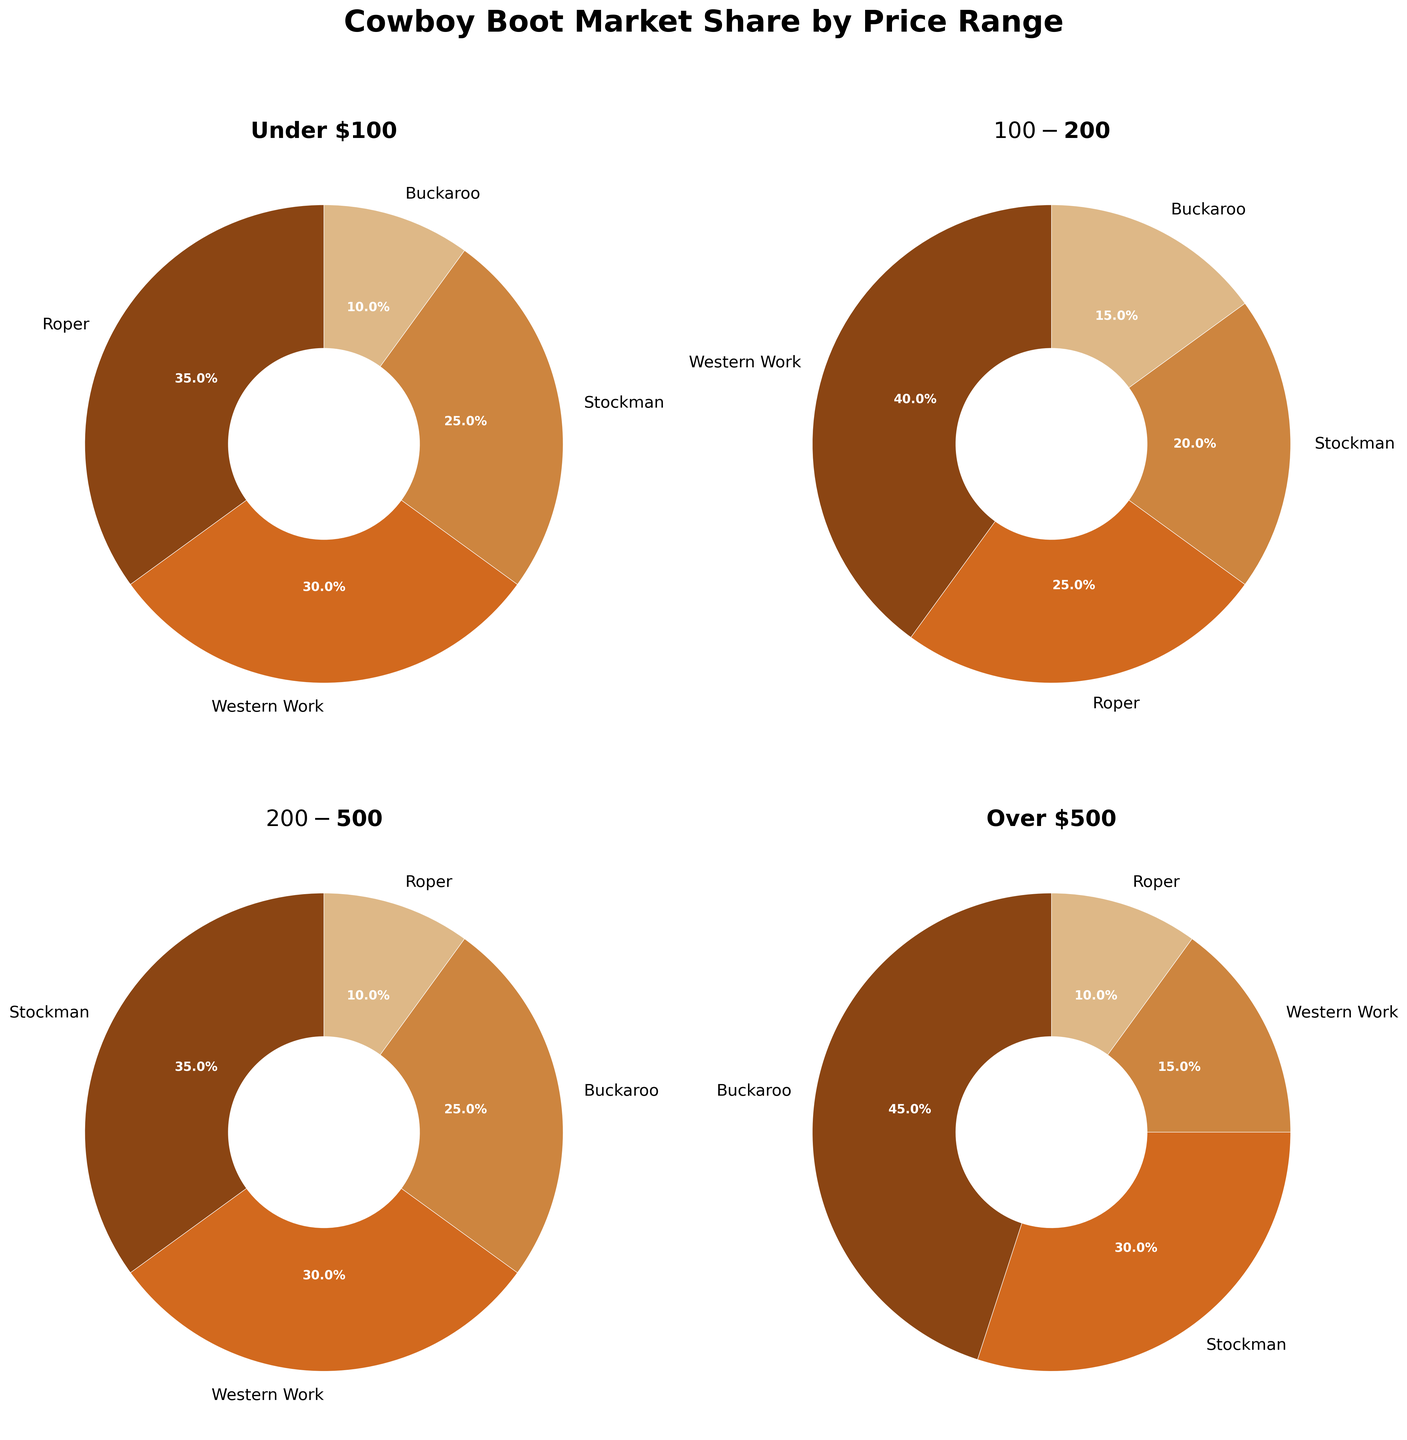What's the most popular boot style under $100? Look at the pie chart for the "Under $100" price range. The largest slice of the pie chart corresponds to the "Roper" style with 35%.
Answer: Roper Which style got the most market share in the $100-$200 range? Refer to the pie chart for the "$100-$200" range and identify the largest segment. "Western Work" has the highest market share with 40%.
Answer: Western Work Which price range has the highest market share for Buckaroo boots? Compare the market share percentages of Buckaroo boots across all price ranges. The "Over $500" range has the highest share at 45%.
Answer: Over $500 What's the combined market share of Stockman boots in the under $100 and $100-$200 ranges? Add the market shares of Stockman boots in the "Under $100" and "$100-$200" ranges. 25% + 20% = 45%.
Answer: 45% Which style has the smallest market share in the $200-$500 range? Locate the pie chart for the "$200-$500" range and identify the smallest segment. "Roper" has the smallest market share with 10%.
Answer: Roper In the over $500 price range, how does the market share of Buckaroo boots compare to Western Work boots? Find the market share percentages for Buckaroo and Western Work boots in the "Over $500" range. Buckaroo has 45% while Western Work has 15%, so Buckaroo is higher.
Answer: Buckaroo is higher Which style has a consistent market share across all the price ranges? Check the market share percentages for each style in all price ranges. "Roper" appears in all price ranges with varying shares but seems less consistently dominant. None have a constant market share across all ranges.
Answer: None What's the total market share for Western Work boots across the $100-$200 and $200-$500 ranges? Sum the market shares of Western Work boots in the "$100-$200" and "$200-$500" ranges. 40% + 30% = 70%.
Answer: 70% How does the market share for Stockman boots differ between the $100-$200 and $200-$500 ranges? Subtract the market share of Stockman boots in the "$100-$200" range from that in the "$200-$500" range. 35% - 20% = 15%.
Answer: 15% higher Across all price ranges, which boot style shows up the least in terms of market share percentage? Look at all the pie charts and identify the style with the consistently smallest market shares. "Roper" often has the smallest share, especially in higher price ranges.
Answer: Roper 